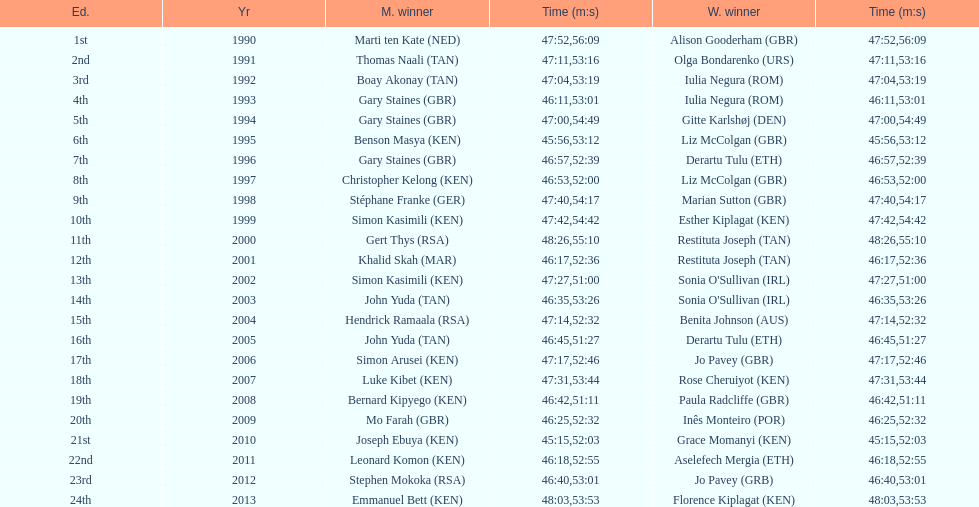What is the difference in finishing times for the men's and women's bupa great south run finish for 2013? 5:50. 